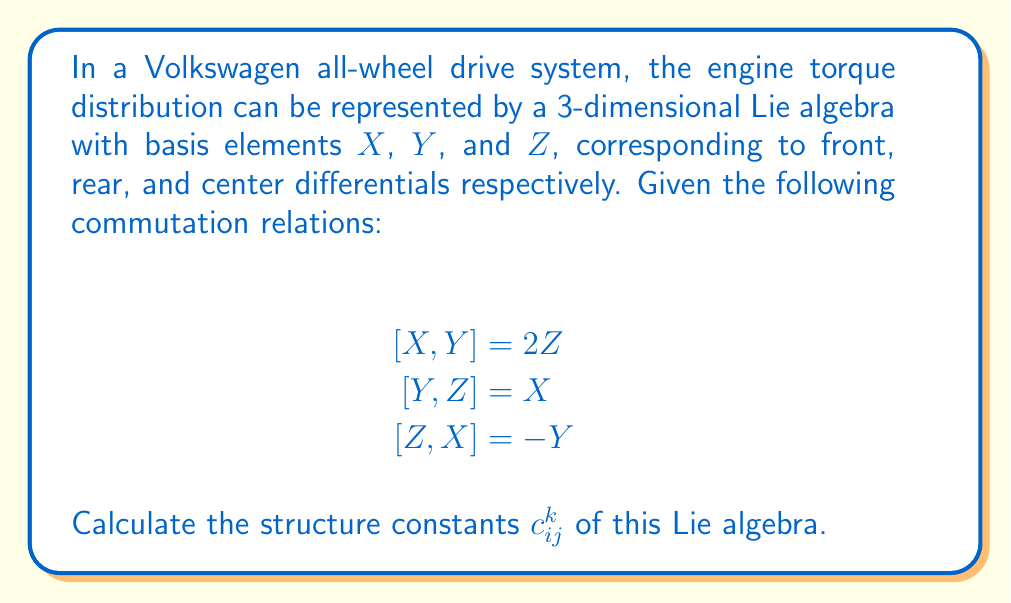Help me with this question. To solve this problem, we need to understand the concept of structure constants in Lie algebras and how they relate to the given commutation relations. Let's break it down step-by-step:

1) Structure constants are defined by the equation:

   $$[X_i, X_j] = \sum_k c_{ij}^k X_k$$

   where $X_i$, $X_j$, and $X_k$ are basis elements of the Lie algebra.

2) In our case, we have three basis elements: $X$, $Y$, and $Z$. We can assign them indices as follows:
   $X_1 = X$, $X_2 = Y$, $X_3 = Z$

3) Now, let's analyze each commutation relation:

   a) $[X,Y] = 2Z$
      This means $[X_1, X_2] = 2X_3$, so $c_{12}^3 = 2$ and $c_{12}^1 = c_{12}^2 = 0$

   b) $[Y,Z] = X$
      This means $[X_2, X_3] = X_1$, so $c_{23}^1 = 1$ and $c_{23}^2 = c_{23}^3 = 0$

   c) $[Z,X] = -Y$
      This means $[X_3, X_1] = -X_2$, so $c_{31}^2 = -1$ and $c_{31}^1 = c_{31}^3 = 0$

4) Remember that the structure constants are antisymmetric in the lower indices:
   $c_{ij}^k = -c_{ji}^k$

   So, we can deduce:
   $c_{21}^3 = -2$, $c_{32}^1 = -1$, $c_{13}^2 = 1$

5) All other structure constants not mentioned are zero.
Answer: The non-zero structure constants are:

$c_{12}^3 = 2$, $c_{23}^1 = 1$, $c_{31}^2 = -1$
$c_{21}^3 = -2$, $c_{32}^1 = -1$, $c_{13}^2 = 1$

All other $c_{ij}^k = 0$ 